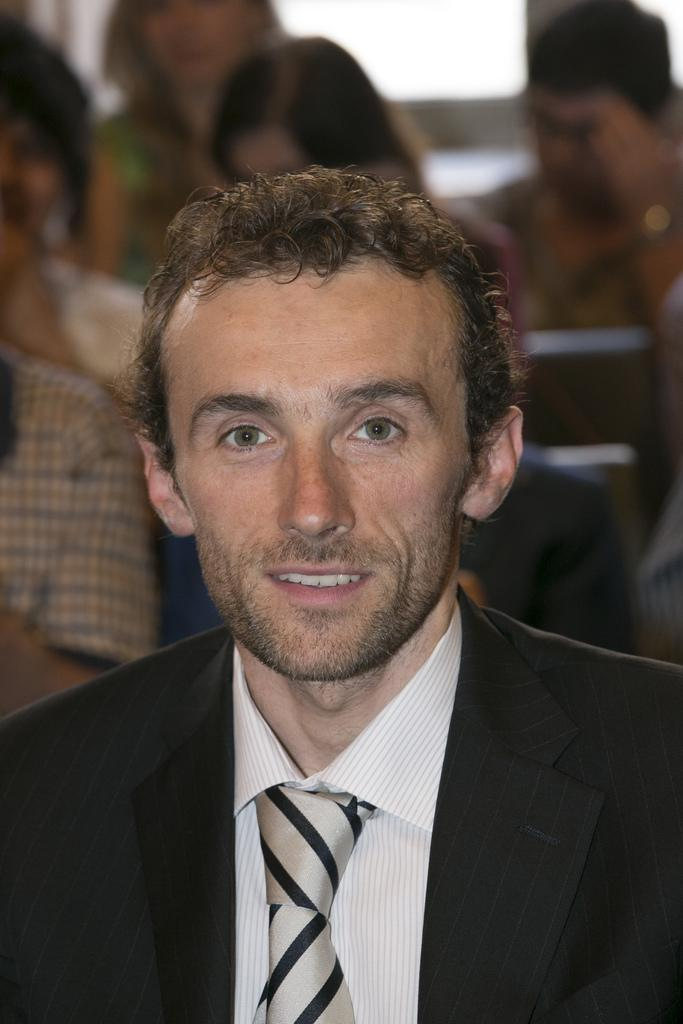Who is the main subject in the image? There is a man in the image. What is the man wearing in the image? The man is wearing a black blazer. Can you describe the background of the image? There are groups of people behind the man. How many fingers does the cow have in the image? There is no cow present in the image, so it is not possible to determine the number of fingers it might have. 